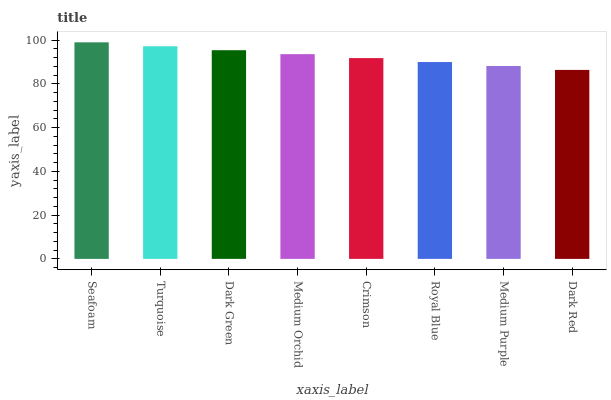Is Dark Red the minimum?
Answer yes or no. Yes. Is Seafoam the maximum?
Answer yes or no. Yes. Is Turquoise the minimum?
Answer yes or no. No. Is Turquoise the maximum?
Answer yes or no. No. Is Seafoam greater than Turquoise?
Answer yes or no. Yes. Is Turquoise less than Seafoam?
Answer yes or no. Yes. Is Turquoise greater than Seafoam?
Answer yes or no. No. Is Seafoam less than Turquoise?
Answer yes or no. No. Is Medium Orchid the high median?
Answer yes or no. Yes. Is Crimson the low median?
Answer yes or no. Yes. Is Dark Red the high median?
Answer yes or no. No. Is Medium Purple the low median?
Answer yes or no. No. 